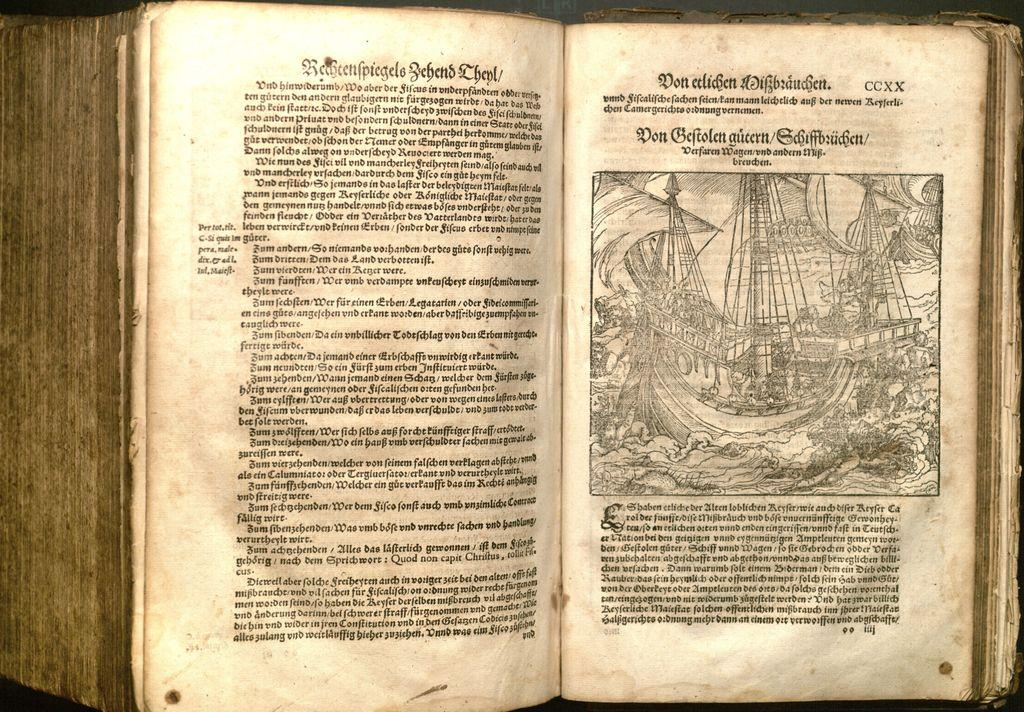<image>
Give a short and clear explanation of the subsequent image. A book written in a foreign language, but the top right page displays a CCXX in the corner. 